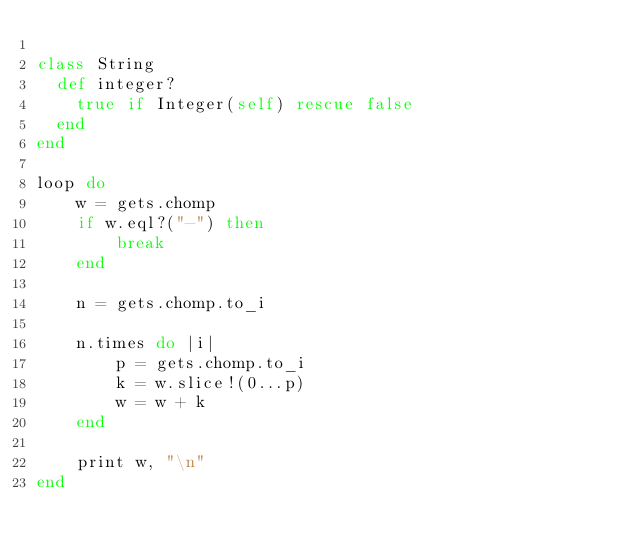Convert code to text. <code><loc_0><loc_0><loc_500><loc_500><_Ruby_>
class String
  def integer?
    true if Integer(self) rescue false
  end
end

loop do
    w = gets.chomp
    if w.eql?("-") then
        break
    end
    
    n = gets.chomp.to_i
    
    n.times do |i|
        p = gets.chomp.to_i
        k = w.slice!(0...p)
        w = w + k
    end

    print w, "\n"
end

</code> 